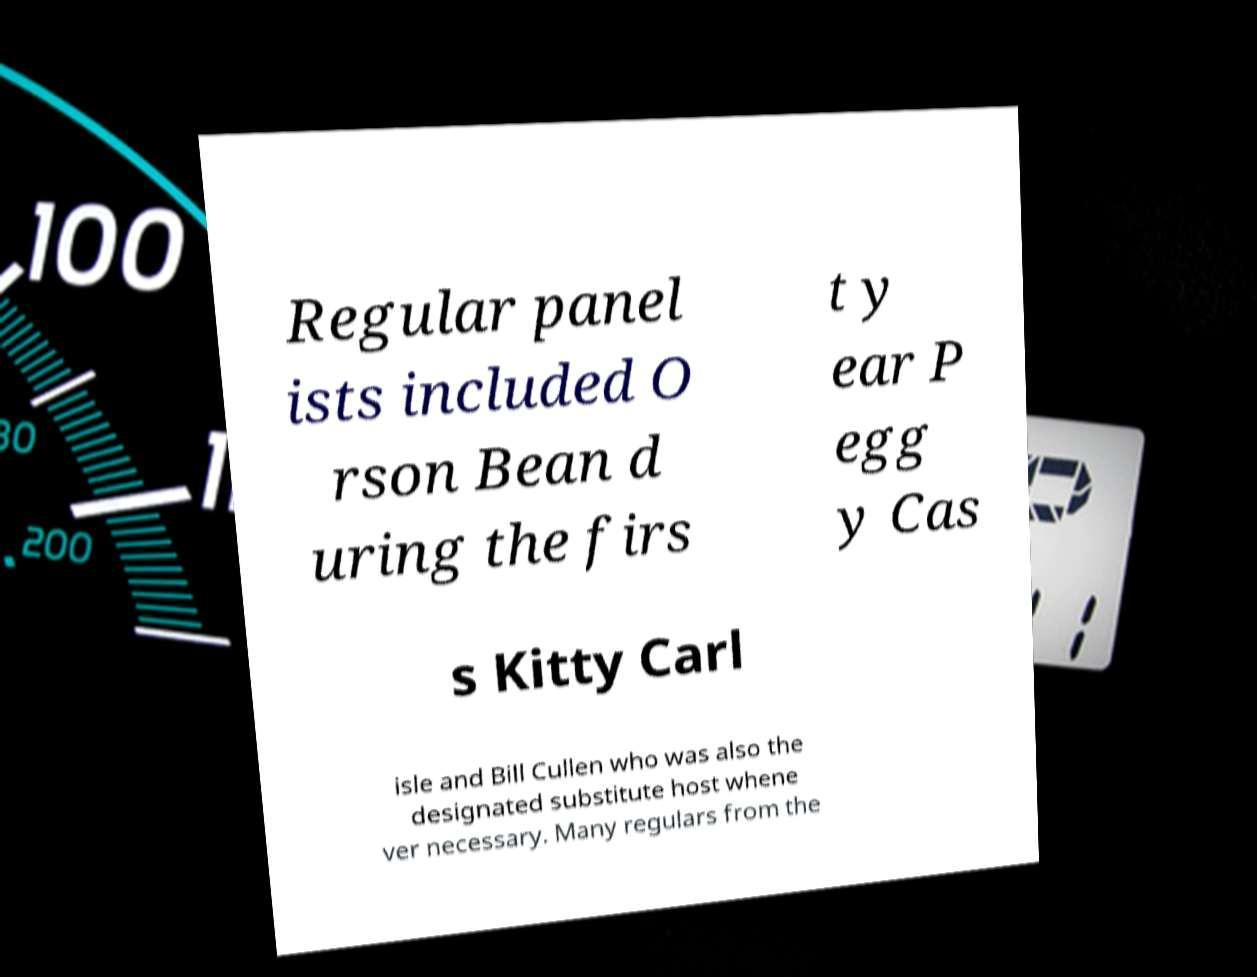For documentation purposes, I need the text within this image transcribed. Could you provide that? Regular panel ists included O rson Bean d uring the firs t y ear P egg y Cas s Kitty Carl isle and Bill Cullen who was also the designated substitute host whene ver necessary. Many regulars from the 